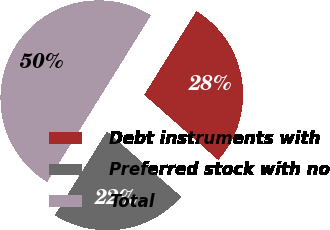Convert chart. <chart><loc_0><loc_0><loc_500><loc_500><pie_chart><fcel>Debt instruments with<fcel>Preferred stock with no<fcel>Total<nl><fcel>27.63%<fcel>22.37%<fcel>50.0%<nl></chart> 